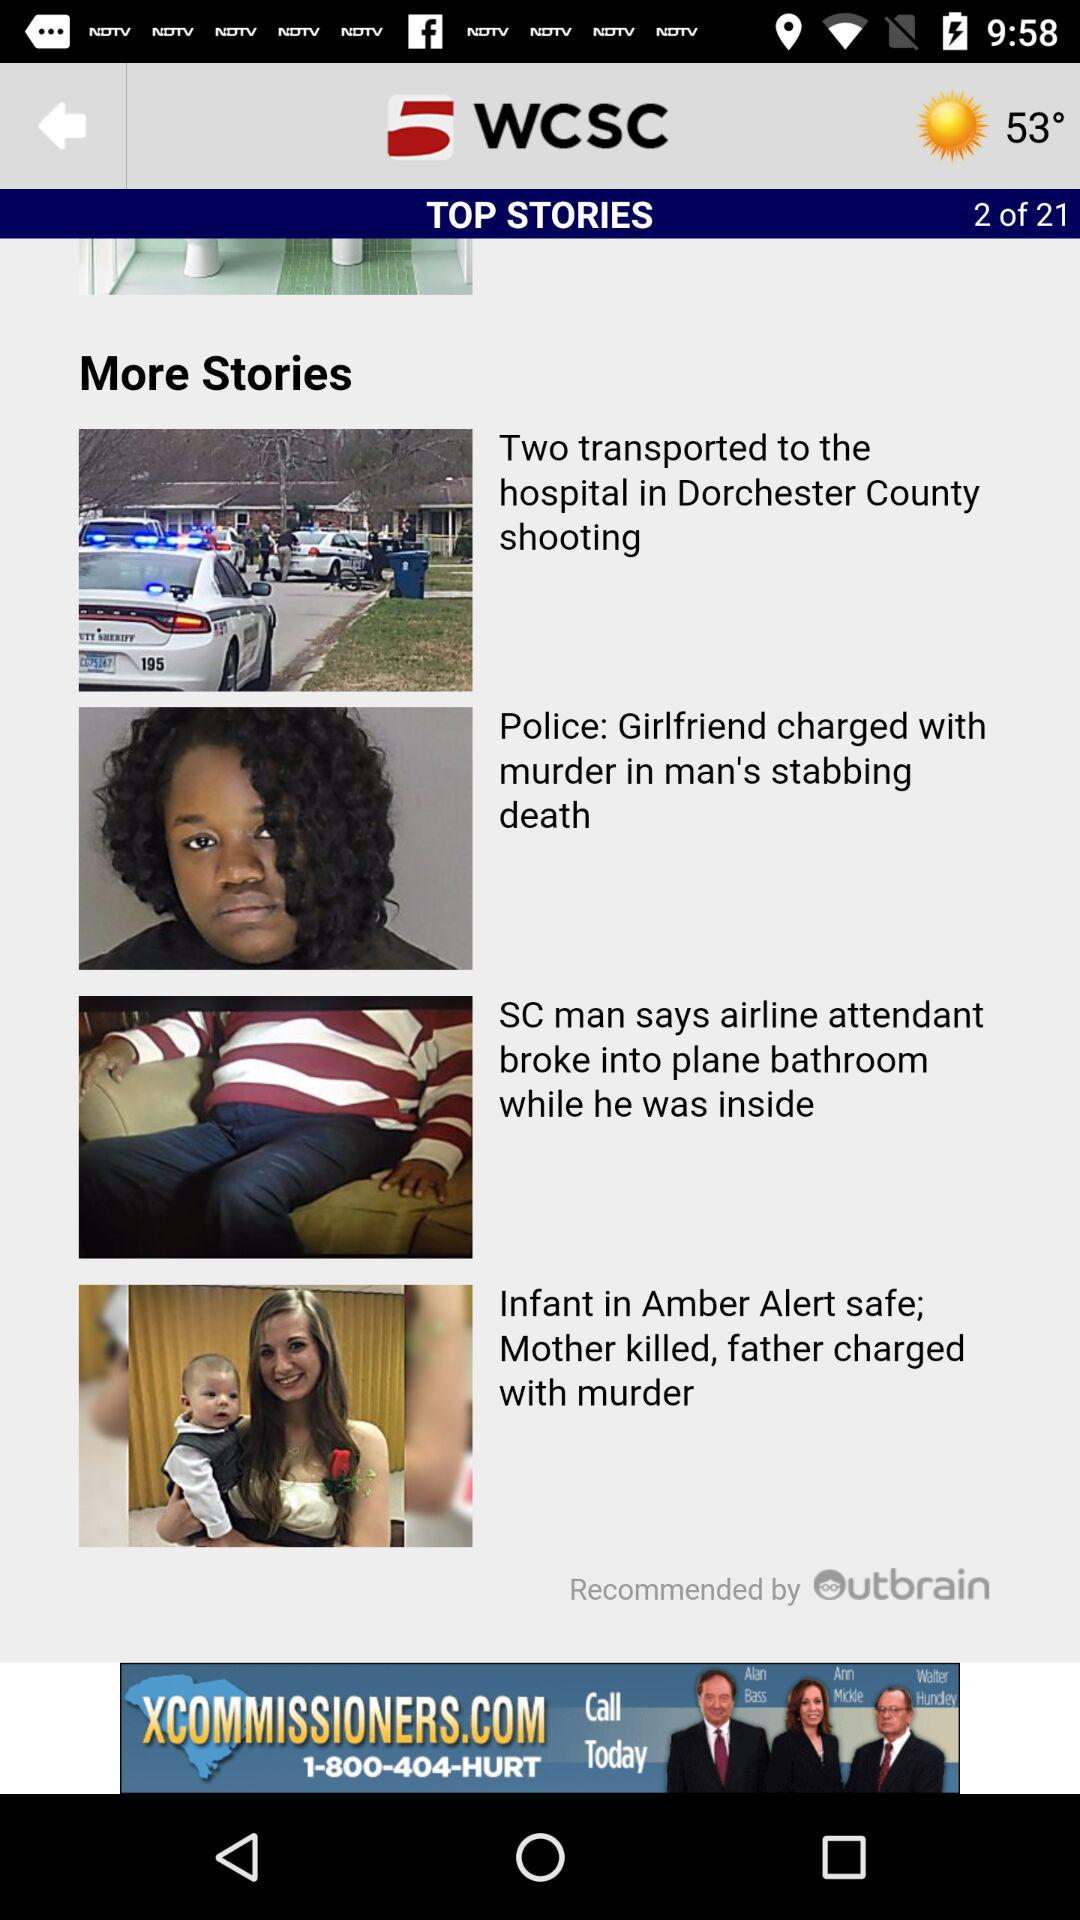What is the temperature? The temperature is 53°. 